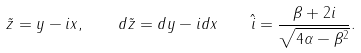Convert formula to latex. <formula><loc_0><loc_0><loc_500><loc_500>\quad \tilde { z } = y - i x , \quad d \tilde { z } = d y - i d x \quad \hat { i } = \frac { \beta + 2 i } { \sqrt { 4 \alpha - \beta ^ { 2 } } } .</formula> 